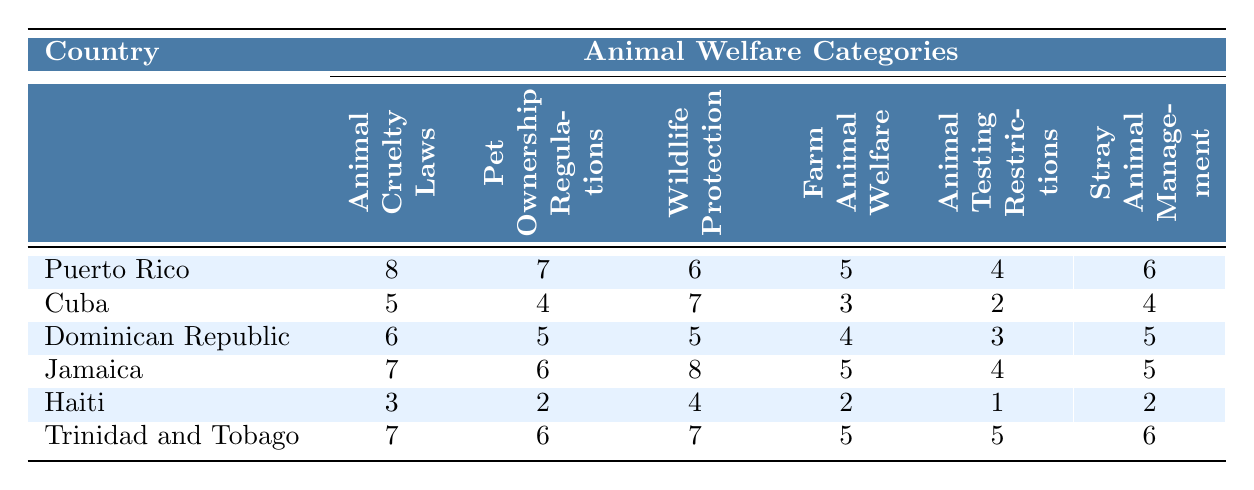What country has the highest Animal Cruelty Laws index? The table shows that Puerto Rico has the highest score for Animal Cruelty Laws with a value of 8.
Answer: Puerto Rico Which country ranks lowest in Pet Ownership Regulations? By reviewing the Pet Ownership Regulations column, Haiti has the lowest score at 2.
Answer: Haiti What is the total score for Wildlife Protection across all countries? Adding the values for Wildlife Protection: 6 (Puerto Rico) + 7 (Cuba) + 5 (Dominican Republic) + 8 (Jamaica) + 4 (Haiti) + 7 (Trinidad and Tobago) gives us a total of 37.
Answer: 37 Which country has better Stray Animal Management, Jamaica or Cuba? Jamaica has a score of 5 while Cuba has a score of 4 in Stray Animal Management, indicating that Jamaica has better management.
Answer: Jamaica Is there a country that has a score of 5 in both Animal Cruelty Laws and Farm Animal Welfare? Looking at the table, the Dominican Republic has a score of 6 in Animal Cruelty Laws and 4 in Farm Animal Welfare, neither matches the criteria, thus the answer is no.
Answer: No What is the average score for Animal Testing Restrictions across all countries? The scores are 4 (Puerto Rico), 2 (Cuba), 3 (Dominican Republic), 4 (Jamaica), 1 (Haiti), and 5 (Trinidad and Tobago). Summing these gives 19, and dividing by 6 (the number of countries) results in an average of approximately 3.17.
Answer: 3.17 Which country has the best overall performance in all categories? Comparing the total scores for each country: Puerto Rico (36), Cuba (25), Dominican Republic (23), Jamaica (35), Haiti (12), Trinidad and Tobago (36), both Puerto Rico and Trinidad and Tobago tie for the highest score.
Answer: Puerto Rico and Trinidad and Tobago How many countries have a score of at least 6 in Wildlife Protection? The scores for Wildlife Protection are 6 (Puerto Rico), 7 (Cuba), 5 (Dominican Republic), 8 (Jamaica), 4 (Haiti), and 7 (Trinidad and Tobago). Therefore, there are 4 countries with scores of at least 6.
Answer: 4 Which country has a higher score in Farm Animal Welfare, Cuba or the Dominican Republic? Cuba has a score of 3 while the Dominican Republic has a score of 4 in Farm Animal Welfare, indicating that the Dominican Republic has a higher score.
Answer: Dominican Republic Is the average score for Stray Animal Management higher than for Animal Testing Restrictions? The Stray Animal Management scores are 6 (Puerto Rico), 4 (Cuba), 5 (Dominican Republic), 5 (Jamaica), 2 (Haiti), and 6 (Trinidad and Tobago). Their average is 4.67. The Animal Testing Restrictions scores are 4 (Puerto Rico), 2 (Cuba), 3 (Dominican Republic), 4 (Jamaica), 1 (Haiti), and 5 (Trinidad and Tobago), with an average of 3. The average for Stray Animal Management is higher.
Answer: Yes 